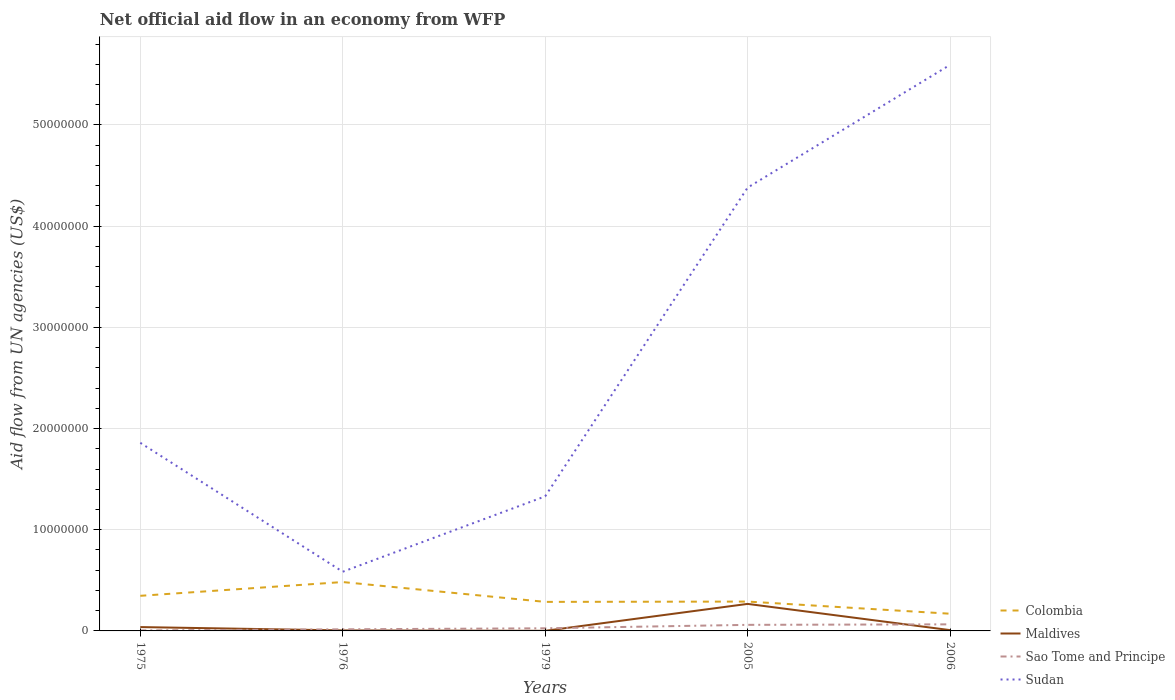How many different coloured lines are there?
Ensure brevity in your answer.  4. Does the line corresponding to Maldives intersect with the line corresponding to Sao Tome and Principe?
Ensure brevity in your answer.  Yes. In which year was the net official aid flow in Colombia maximum?
Ensure brevity in your answer.  2006. What is the total net official aid flow in Sao Tome and Principe in the graph?
Offer a terse response. -3.40e+05. What is the difference between the highest and the second highest net official aid flow in Sudan?
Provide a short and direct response. 5.01e+07. Is the net official aid flow in Maldives strictly greater than the net official aid flow in Sudan over the years?
Give a very brief answer. Yes. How many years are there in the graph?
Ensure brevity in your answer.  5. Are the values on the major ticks of Y-axis written in scientific E-notation?
Provide a succinct answer. No. Does the graph contain any zero values?
Ensure brevity in your answer.  No. How are the legend labels stacked?
Ensure brevity in your answer.  Vertical. What is the title of the graph?
Offer a very short reply. Net official aid flow in an economy from WFP. Does "Marshall Islands" appear as one of the legend labels in the graph?
Offer a terse response. No. What is the label or title of the X-axis?
Make the answer very short. Years. What is the label or title of the Y-axis?
Your answer should be compact. Aid flow from UN agencies (US$). What is the Aid flow from UN agencies (US$) in Colombia in 1975?
Your response must be concise. 3.47e+06. What is the Aid flow from UN agencies (US$) of Sudan in 1975?
Your response must be concise. 1.86e+07. What is the Aid flow from UN agencies (US$) in Colombia in 1976?
Give a very brief answer. 4.83e+06. What is the Aid flow from UN agencies (US$) in Maldives in 1976?
Provide a short and direct response. 5.00e+04. What is the Aid flow from UN agencies (US$) in Sao Tome and Principe in 1976?
Your response must be concise. 1.60e+05. What is the Aid flow from UN agencies (US$) of Sudan in 1976?
Offer a terse response. 5.85e+06. What is the Aid flow from UN agencies (US$) of Colombia in 1979?
Keep it short and to the point. 2.87e+06. What is the Aid flow from UN agencies (US$) in Maldives in 1979?
Make the answer very short. 10000. What is the Aid flow from UN agencies (US$) of Sudan in 1979?
Your answer should be compact. 1.33e+07. What is the Aid flow from UN agencies (US$) of Colombia in 2005?
Offer a terse response. 2.90e+06. What is the Aid flow from UN agencies (US$) in Maldives in 2005?
Your response must be concise. 2.67e+06. What is the Aid flow from UN agencies (US$) in Sao Tome and Principe in 2005?
Provide a succinct answer. 6.00e+05. What is the Aid flow from UN agencies (US$) in Sudan in 2005?
Give a very brief answer. 4.38e+07. What is the Aid flow from UN agencies (US$) of Colombia in 2006?
Ensure brevity in your answer.  1.70e+06. What is the Aid flow from UN agencies (US$) of Sao Tome and Principe in 2006?
Your response must be concise. 6.50e+05. What is the Aid flow from UN agencies (US$) in Sudan in 2006?
Provide a short and direct response. 5.59e+07. Across all years, what is the maximum Aid flow from UN agencies (US$) of Colombia?
Your response must be concise. 4.83e+06. Across all years, what is the maximum Aid flow from UN agencies (US$) of Maldives?
Provide a short and direct response. 2.67e+06. Across all years, what is the maximum Aid flow from UN agencies (US$) of Sao Tome and Principe?
Your response must be concise. 6.50e+05. Across all years, what is the maximum Aid flow from UN agencies (US$) in Sudan?
Your answer should be compact. 5.59e+07. Across all years, what is the minimum Aid flow from UN agencies (US$) in Colombia?
Ensure brevity in your answer.  1.70e+06. Across all years, what is the minimum Aid flow from UN agencies (US$) in Maldives?
Give a very brief answer. 10000. Across all years, what is the minimum Aid flow from UN agencies (US$) of Sudan?
Make the answer very short. 5.85e+06. What is the total Aid flow from UN agencies (US$) of Colombia in the graph?
Your response must be concise. 1.58e+07. What is the total Aid flow from UN agencies (US$) in Maldives in the graph?
Make the answer very short. 3.19e+06. What is the total Aid flow from UN agencies (US$) of Sao Tome and Principe in the graph?
Ensure brevity in your answer.  1.72e+06. What is the total Aid flow from UN agencies (US$) of Sudan in the graph?
Give a very brief answer. 1.37e+08. What is the difference between the Aid flow from UN agencies (US$) of Colombia in 1975 and that in 1976?
Your answer should be very brief. -1.36e+06. What is the difference between the Aid flow from UN agencies (US$) in Maldives in 1975 and that in 1976?
Offer a very short reply. 3.30e+05. What is the difference between the Aid flow from UN agencies (US$) in Sao Tome and Principe in 1975 and that in 1976?
Provide a short and direct response. -1.10e+05. What is the difference between the Aid flow from UN agencies (US$) of Sudan in 1975 and that in 1976?
Offer a very short reply. 1.27e+07. What is the difference between the Aid flow from UN agencies (US$) in Sudan in 1975 and that in 1979?
Your response must be concise. 5.29e+06. What is the difference between the Aid flow from UN agencies (US$) of Colombia in 1975 and that in 2005?
Ensure brevity in your answer.  5.70e+05. What is the difference between the Aid flow from UN agencies (US$) in Maldives in 1975 and that in 2005?
Your answer should be very brief. -2.29e+06. What is the difference between the Aid flow from UN agencies (US$) in Sao Tome and Principe in 1975 and that in 2005?
Keep it short and to the point. -5.50e+05. What is the difference between the Aid flow from UN agencies (US$) in Sudan in 1975 and that in 2005?
Provide a short and direct response. -2.52e+07. What is the difference between the Aid flow from UN agencies (US$) of Colombia in 1975 and that in 2006?
Provide a succinct answer. 1.77e+06. What is the difference between the Aid flow from UN agencies (US$) of Maldives in 1975 and that in 2006?
Provide a short and direct response. 3.00e+05. What is the difference between the Aid flow from UN agencies (US$) of Sao Tome and Principe in 1975 and that in 2006?
Keep it short and to the point. -6.00e+05. What is the difference between the Aid flow from UN agencies (US$) in Sudan in 1975 and that in 2006?
Offer a terse response. -3.74e+07. What is the difference between the Aid flow from UN agencies (US$) in Colombia in 1976 and that in 1979?
Your answer should be very brief. 1.96e+06. What is the difference between the Aid flow from UN agencies (US$) in Maldives in 1976 and that in 1979?
Ensure brevity in your answer.  4.00e+04. What is the difference between the Aid flow from UN agencies (US$) of Sudan in 1976 and that in 1979?
Your response must be concise. -7.45e+06. What is the difference between the Aid flow from UN agencies (US$) of Colombia in 1976 and that in 2005?
Make the answer very short. 1.93e+06. What is the difference between the Aid flow from UN agencies (US$) of Maldives in 1976 and that in 2005?
Provide a succinct answer. -2.62e+06. What is the difference between the Aid flow from UN agencies (US$) of Sao Tome and Principe in 1976 and that in 2005?
Make the answer very short. -4.40e+05. What is the difference between the Aid flow from UN agencies (US$) of Sudan in 1976 and that in 2005?
Your response must be concise. -3.80e+07. What is the difference between the Aid flow from UN agencies (US$) in Colombia in 1976 and that in 2006?
Provide a short and direct response. 3.13e+06. What is the difference between the Aid flow from UN agencies (US$) of Maldives in 1976 and that in 2006?
Provide a short and direct response. -3.00e+04. What is the difference between the Aid flow from UN agencies (US$) in Sao Tome and Principe in 1976 and that in 2006?
Make the answer very short. -4.90e+05. What is the difference between the Aid flow from UN agencies (US$) of Sudan in 1976 and that in 2006?
Your response must be concise. -5.01e+07. What is the difference between the Aid flow from UN agencies (US$) of Maldives in 1979 and that in 2005?
Keep it short and to the point. -2.66e+06. What is the difference between the Aid flow from UN agencies (US$) of Sudan in 1979 and that in 2005?
Ensure brevity in your answer.  -3.05e+07. What is the difference between the Aid flow from UN agencies (US$) in Colombia in 1979 and that in 2006?
Offer a terse response. 1.17e+06. What is the difference between the Aid flow from UN agencies (US$) of Sao Tome and Principe in 1979 and that in 2006?
Offer a terse response. -3.90e+05. What is the difference between the Aid flow from UN agencies (US$) in Sudan in 1979 and that in 2006?
Offer a terse response. -4.26e+07. What is the difference between the Aid flow from UN agencies (US$) in Colombia in 2005 and that in 2006?
Provide a succinct answer. 1.20e+06. What is the difference between the Aid flow from UN agencies (US$) of Maldives in 2005 and that in 2006?
Your answer should be very brief. 2.59e+06. What is the difference between the Aid flow from UN agencies (US$) in Sudan in 2005 and that in 2006?
Your answer should be very brief. -1.21e+07. What is the difference between the Aid flow from UN agencies (US$) of Colombia in 1975 and the Aid flow from UN agencies (US$) of Maldives in 1976?
Your response must be concise. 3.42e+06. What is the difference between the Aid flow from UN agencies (US$) of Colombia in 1975 and the Aid flow from UN agencies (US$) of Sao Tome and Principe in 1976?
Ensure brevity in your answer.  3.31e+06. What is the difference between the Aid flow from UN agencies (US$) of Colombia in 1975 and the Aid flow from UN agencies (US$) of Sudan in 1976?
Offer a terse response. -2.38e+06. What is the difference between the Aid flow from UN agencies (US$) of Maldives in 1975 and the Aid flow from UN agencies (US$) of Sudan in 1976?
Offer a terse response. -5.47e+06. What is the difference between the Aid flow from UN agencies (US$) of Sao Tome and Principe in 1975 and the Aid flow from UN agencies (US$) of Sudan in 1976?
Your answer should be compact. -5.80e+06. What is the difference between the Aid flow from UN agencies (US$) in Colombia in 1975 and the Aid flow from UN agencies (US$) in Maldives in 1979?
Ensure brevity in your answer.  3.46e+06. What is the difference between the Aid flow from UN agencies (US$) in Colombia in 1975 and the Aid flow from UN agencies (US$) in Sao Tome and Principe in 1979?
Keep it short and to the point. 3.21e+06. What is the difference between the Aid flow from UN agencies (US$) in Colombia in 1975 and the Aid flow from UN agencies (US$) in Sudan in 1979?
Provide a succinct answer. -9.83e+06. What is the difference between the Aid flow from UN agencies (US$) of Maldives in 1975 and the Aid flow from UN agencies (US$) of Sao Tome and Principe in 1979?
Offer a terse response. 1.20e+05. What is the difference between the Aid flow from UN agencies (US$) of Maldives in 1975 and the Aid flow from UN agencies (US$) of Sudan in 1979?
Offer a very short reply. -1.29e+07. What is the difference between the Aid flow from UN agencies (US$) in Sao Tome and Principe in 1975 and the Aid flow from UN agencies (US$) in Sudan in 1979?
Your answer should be compact. -1.32e+07. What is the difference between the Aid flow from UN agencies (US$) in Colombia in 1975 and the Aid flow from UN agencies (US$) in Maldives in 2005?
Your answer should be compact. 8.00e+05. What is the difference between the Aid flow from UN agencies (US$) in Colombia in 1975 and the Aid flow from UN agencies (US$) in Sao Tome and Principe in 2005?
Give a very brief answer. 2.87e+06. What is the difference between the Aid flow from UN agencies (US$) of Colombia in 1975 and the Aid flow from UN agencies (US$) of Sudan in 2005?
Your answer should be compact. -4.03e+07. What is the difference between the Aid flow from UN agencies (US$) of Maldives in 1975 and the Aid flow from UN agencies (US$) of Sao Tome and Principe in 2005?
Keep it short and to the point. -2.20e+05. What is the difference between the Aid flow from UN agencies (US$) of Maldives in 1975 and the Aid flow from UN agencies (US$) of Sudan in 2005?
Make the answer very short. -4.34e+07. What is the difference between the Aid flow from UN agencies (US$) of Sao Tome and Principe in 1975 and the Aid flow from UN agencies (US$) of Sudan in 2005?
Your response must be concise. -4.38e+07. What is the difference between the Aid flow from UN agencies (US$) of Colombia in 1975 and the Aid flow from UN agencies (US$) of Maldives in 2006?
Keep it short and to the point. 3.39e+06. What is the difference between the Aid flow from UN agencies (US$) in Colombia in 1975 and the Aid flow from UN agencies (US$) in Sao Tome and Principe in 2006?
Your answer should be very brief. 2.82e+06. What is the difference between the Aid flow from UN agencies (US$) in Colombia in 1975 and the Aid flow from UN agencies (US$) in Sudan in 2006?
Your response must be concise. -5.25e+07. What is the difference between the Aid flow from UN agencies (US$) in Maldives in 1975 and the Aid flow from UN agencies (US$) in Sao Tome and Principe in 2006?
Provide a succinct answer. -2.70e+05. What is the difference between the Aid flow from UN agencies (US$) in Maldives in 1975 and the Aid flow from UN agencies (US$) in Sudan in 2006?
Ensure brevity in your answer.  -5.56e+07. What is the difference between the Aid flow from UN agencies (US$) in Sao Tome and Principe in 1975 and the Aid flow from UN agencies (US$) in Sudan in 2006?
Provide a succinct answer. -5.59e+07. What is the difference between the Aid flow from UN agencies (US$) of Colombia in 1976 and the Aid flow from UN agencies (US$) of Maldives in 1979?
Keep it short and to the point. 4.82e+06. What is the difference between the Aid flow from UN agencies (US$) in Colombia in 1976 and the Aid flow from UN agencies (US$) in Sao Tome and Principe in 1979?
Offer a terse response. 4.57e+06. What is the difference between the Aid flow from UN agencies (US$) of Colombia in 1976 and the Aid flow from UN agencies (US$) of Sudan in 1979?
Keep it short and to the point. -8.47e+06. What is the difference between the Aid flow from UN agencies (US$) in Maldives in 1976 and the Aid flow from UN agencies (US$) in Sudan in 1979?
Offer a terse response. -1.32e+07. What is the difference between the Aid flow from UN agencies (US$) of Sao Tome and Principe in 1976 and the Aid flow from UN agencies (US$) of Sudan in 1979?
Provide a succinct answer. -1.31e+07. What is the difference between the Aid flow from UN agencies (US$) in Colombia in 1976 and the Aid flow from UN agencies (US$) in Maldives in 2005?
Offer a very short reply. 2.16e+06. What is the difference between the Aid flow from UN agencies (US$) of Colombia in 1976 and the Aid flow from UN agencies (US$) of Sao Tome and Principe in 2005?
Give a very brief answer. 4.23e+06. What is the difference between the Aid flow from UN agencies (US$) in Colombia in 1976 and the Aid flow from UN agencies (US$) in Sudan in 2005?
Your answer should be compact. -3.90e+07. What is the difference between the Aid flow from UN agencies (US$) of Maldives in 1976 and the Aid flow from UN agencies (US$) of Sao Tome and Principe in 2005?
Make the answer very short. -5.50e+05. What is the difference between the Aid flow from UN agencies (US$) in Maldives in 1976 and the Aid flow from UN agencies (US$) in Sudan in 2005?
Offer a terse response. -4.38e+07. What is the difference between the Aid flow from UN agencies (US$) in Sao Tome and Principe in 1976 and the Aid flow from UN agencies (US$) in Sudan in 2005?
Offer a terse response. -4.36e+07. What is the difference between the Aid flow from UN agencies (US$) in Colombia in 1976 and the Aid flow from UN agencies (US$) in Maldives in 2006?
Offer a very short reply. 4.75e+06. What is the difference between the Aid flow from UN agencies (US$) in Colombia in 1976 and the Aid flow from UN agencies (US$) in Sao Tome and Principe in 2006?
Your answer should be compact. 4.18e+06. What is the difference between the Aid flow from UN agencies (US$) in Colombia in 1976 and the Aid flow from UN agencies (US$) in Sudan in 2006?
Your response must be concise. -5.11e+07. What is the difference between the Aid flow from UN agencies (US$) of Maldives in 1976 and the Aid flow from UN agencies (US$) of Sao Tome and Principe in 2006?
Your answer should be compact. -6.00e+05. What is the difference between the Aid flow from UN agencies (US$) of Maldives in 1976 and the Aid flow from UN agencies (US$) of Sudan in 2006?
Make the answer very short. -5.59e+07. What is the difference between the Aid flow from UN agencies (US$) of Sao Tome and Principe in 1976 and the Aid flow from UN agencies (US$) of Sudan in 2006?
Provide a short and direct response. -5.58e+07. What is the difference between the Aid flow from UN agencies (US$) in Colombia in 1979 and the Aid flow from UN agencies (US$) in Sao Tome and Principe in 2005?
Your response must be concise. 2.27e+06. What is the difference between the Aid flow from UN agencies (US$) of Colombia in 1979 and the Aid flow from UN agencies (US$) of Sudan in 2005?
Keep it short and to the point. -4.09e+07. What is the difference between the Aid flow from UN agencies (US$) in Maldives in 1979 and the Aid flow from UN agencies (US$) in Sao Tome and Principe in 2005?
Keep it short and to the point. -5.90e+05. What is the difference between the Aid flow from UN agencies (US$) in Maldives in 1979 and the Aid flow from UN agencies (US$) in Sudan in 2005?
Ensure brevity in your answer.  -4.38e+07. What is the difference between the Aid flow from UN agencies (US$) in Sao Tome and Principe in 1979 and the Aid flow from UN agencies (US$) in Sudan in 2005?
Your response must be concise. -4.36e+07. What is the difference between the Aid flow from UN agencies (US$) of Colombia in 1979 and the Aid flow from UN agencies (US$) of Maldives in 2006?
Your response must be concise. 2.79e+06. What is the difference between the Aid flow from UN agencies (US$) of Colombia in 1979 and the Aid flow from UN agencies (US$) of Sao Tome and Principe in 2006?
Give a very brief answer. 2.22e+06. What is the difference between the Aid flow from UN agencies (US$) of Colombia in 1979 and the Aid flow from UN agencies (US$) of Sudan in 2006?
Ensure brevity in your answer.  -5.31e+07. What is the difference between the Aid flow from UN agencies (US$) in Maldives in 1979 and the Aid flow from UN agencies (US$) in Sao Tome and Principe in 2006?
Offer a terse response. -6.40e+05. What is the difference between the Aid flow from UN agencies (US$) in Maldives in 1979 and the Aid flow from UN agencies (US$) in Sudan in 2006?
Provide a short and direct response. -5.59e+07. What is the difference between the Aid flow from UN agencies (US$) of Sao Tome and Principe in 1979 and the Aid flow from UN agencies (US$) of Sudan in 2006?
Ensure brevity in your answer.  -5.57e+07. What is the difference between the Aid flow from UN agencies (US$) in Colombia in 2005 and the Aid flow from UN agencies (US$) in Maldives in 2006?
Your answer should be compact. 2.82e+06. What is the difference between the Aid flow from UN agencies (US$) of Colombia in 2005 and the Aid flow from UN agencies (US$) of Sao Tome and Principe in 2006?
Provide a short and direct response. 2.25e+06. What is the difference between the Aid flow from UN agencies (US$) of Colombia in 2005 and the Aid flow from UN agencies (US$) of Sudan in 2006?
Your answer should be compact. -5.30e+07. What is the difference between the Aid flow from UN agencies (US$) of Maldives in 2005 and the Aid flow from UN agencies (US$) of Sao Tome and Principe in 2006?
Your answer should be compact. 2.02e+06. What is the difference between the Aid flow from UN agencies (US$) of Maldives in 2005 and the Aid flow from UN agencies (US$) of Sudan in 2006?
Give a very brief answer. -5.33e+07. What is the difference between the Aid flow from UN agencies (US$) of Sao Tome and Principe in 2005 and the Aid flow from UN agencies (US$) of Sudan in 2006?
Provide a short and direct response. -5.53e+07. What is the average Aid flow from UN agencies (US$) in Colombia per year?
Your response must be concise. 3.15e+06. What is the average Aid flow from UN agencies (US$) of Maldives per year?
Offer a terse response. 6.38e+05. What is the average Aid flow from UN agencies (US$) of Sao Tome and Principe per year?
Ensure brevity in your answer.  3.44e+05. What is the average Aid flow from UN agencies (US$) in Sudan per year?
Ensure brevity in your answer.  2.75e+07. In the year 1975, what is the difference between the Aid flow from UN agencies (US$) of Colombia and Aid flow from UN agencies (US$) of Maldives?
Provide a succinct answer. 3.09e+06. In the year 1975, what is the difference between the Aid flow from UN agencies (US$) of Colombia and Aid flow from UN agencies (US$) of Sao Tome and Principe?
Offer a terse response. 3.42e+06. In the year 1975, what is the difference between the Aid flow from UN agencies (US$) of Colombia and Aid flow from UN agencies (US$) of Sudan?
Your answer should be compact. -1.51e+07. In the year 1975, what is the difference between the Aid flow from UN agencies (US$) in Maldives and Aid flow from UN agencies (US$) in Sao Tome and Principe?
Make the answer very short. 3.30e+05. In the year 1975, what is the difference between the Aid flow from UN agencies (US$) in Maldives and Aid flow from UN agencies (US$) in Sudan?
Your answer should be very brief. -1.82e+07. In the year 1975, what is the difference between the Aid flow from UN agencies (US$) of Sao Tome and Principe and Aid flow from UN agencies (US$) of Sudan?
Offer a very short reply. -1.85e+07. In the year 1976, what is the difference between the Aid flow from UN agencies (US$) in Colombia and Aid flow from UN agencies (US$) in Maldives?
Make the answer very short. 4.78e+06. In the year 1976, what is the difference between the Aid flow from UN agencies (US$) in Colombia and Aid flow from UN agencies (US$) in Sao Tome and Principe?
Offer a terse response. 4.67e+06. In the year 1976, what is the difference between the Aid flow from UN agencies (US$) of Colombia and Aid flow from UN agencies (US$) of Sudan?
Your answer should be compact. -1.02e+06. In the year 1976, what is the difference between the Aid flow from UN agencies (US$) of Maldives and Aid flow from UN agencies (US$) of Sudan?
Ensure brevity in your answer.  -5.80e+06. In the year 1976, what is the difference between the Aid flow from UN agencies (US$) in Sao Tome and Principe and Aid flow from UN agencies (US$) in Sudan?
Give a very brief answer. -5.69e+06. In the year 1979, what is the difference between the Aid flow from UN agencies (US$) in Colombia and Aid flow from UN agencies (US$) in Maldives?
Provide a short and direct response. 2.86e+06. In the year 1979, what is the difference between the Aid flow from UN agencies (US$) of Colombia and Aid flow from UN agencies (US$) of Sao Tome and Principe?
Offer a terse response. 2.61e+06. In the year 1979, what is the difference between the Aid flow from UN agencies (US$) in Colombia and Aid flow from UN agencies (US$) in Sudan?
Your response must be concise. -1.04e+07. In the year 1979, what is the difference between the Aid flow from UN agencies (US$) of Maldives and Aid flow from UN agencies (US$) of Sudan?
Your answer should be compact. -1.33e+07. In the year 1979, what is the difference between the Aid flow from UN agencies (US$) of Sao Tome and Principe and Aid flow from UN agencies (US$) of Sudan?
Your answer should be compact. -1.30e+07. In the year 2005, what is the difference between the Aid flow from UN agencies (US$) in Colombia and Aid flow from UN agencies (US$) in Maldives?
Provide a succinct answer. 2.30e+05. In the year 2005, what is the difference between the Aid flow from UN agencies (US$) of Colombia and Aid flow from UN agencies (US$) of Sao Tome and Principe?
Ensure brevity in your answer.  2.30e+06. In the year 2005, what is the difference between the Aid flow from UN agencies (US$) of Colombia and Aid flow from UN agencies (US$) of Sudan?
Offer a very short reply. -4.09e+07. In the year 2005, what is the difference between the Aid flow from UN agencies (US$) in Maldives and Aid flow from UN agencies (US$) in Sao Tome and Principe?
Offer a terse response. 2.07e+06. In the year 2005, what is the difference between the Aid flow from UN agencies (US$) of Maldives and Aid flow from UN agencies (US$) of Sudan?
Your answer should be very brief. -4.11e+07. In the year 2005, what is the difference between the Aid flow from UN agencies (US$) in Sao Tome and Principe and Aid flow from UN agencies (US$) in Sudan?
Give a very brief answer. -4.32e+07. In the year 2006, what is the difference between the Aid flow from UN agencies (US$) in Colombia and Aid flow from UN agencies (US$) in Maldives?
Give a very brief answer. 1.62e+06. In the year 2006, what is the difference between the Aid flow from UN agencies (US$) in Colombia and Aid flow from UN agencies (US$) in Sao Tome and Principe?
Offer a very short reply. 1.05e+06. In the year 2006, what is the difference between the Aid flow from UN agencies (US$) in Colombia and Aid flow from UN agencies (US$) in Sudan?
Offer a very short reply. -5.42e+07. In the year 2006, what is the difference between the Aid flow from UN agencies (US$) in Maldives and Aid flow from UN agencies (US$) in Sao Tome and Principe?
Your answer should be compact. -5.70e+05. In the year 2006, what is the difference between the Aid flow from UN agencies (US$) of Maldives and Aid flow from UN agencies (US$) of Sudan?
Offer a terse response. -5.59e+07. In the year 2006, what is the difference between the Aid flow from UN agencies (US$) in Sao Tome and Principe and Aid flow from UN agencies (US$) in Sudan?
Offer a terse response. -5.53e+07. What is the ratio of the Aid flow from UN agencies (US$) in Colombia in 1975 to that in 1976?
Offer a very short reply. 0.72. What is the ratio of the Aid flow from UN agencies (US$) of Sao Tome and Principe in 1975 to that in 1976?
Your answer should be very brief. 0.31. What is the ratio of the Aid flow from UN agencies (US$) in Sudan in 1975 to that in 1976?
Keep it short and to the point. 3.18. What is the ratio of the Aid flow from UN agencies (US$) of Colombia in 1975 to that in 1979?
Your answer should be very brief. 1.21. What is the ratio of the Aid flow from UN agencies (US$) of Sao Tome and Principe in 1975 to that in 1979?
Provide a succinct answer. 0.19. What is the ratio of the Aid flow from UN agencies (US$) of Sudan in 1975 to that in 1979?
Your response must be concise. 1.4. What is the ratio of the Aid flow from UN agencies (US$) in Colombia in 1975 to that in 2005?
Your response must be concise. 1.2. What is the ratio of the Aid flow from UN agencies (US$) of Maldives in 1975 to that in 2005?
Your answer should be compact. 0.14. What is the ratio of the Aid flow from UN agencies (US$) of Sao Tome and Principe in 1975 to that in 2005?
Offer a very short reply. 0.08. What is the ratio of the Aid flow from UN agencies (US$) of Sudan in 1975 to that in 2005?
Make the answer very short. 0.42. What is the ratio of the Aid flow from UN agencies (US$) in Colombia in 1975 to that in 2006?
Ensure brevity in your answer.  2.04. What is the ratio of the Aid flow from UN agencies (US$) of Maldives in 1975 to that in 2006?
Give a very brief answer. 4.75. What is the ratio of the Aid flow from UN agencies (US$) of Sao Tome and Principe in 1975 to that in 2006?
Offer a very short reply. 0.08. What is the ratio of the Aid flow from UN agencies (US$) in Sudan in 1975 to that in 2006?
Keep it short and to the point. 0.33. What is the ratio of the Aid flow from UN agencies (US$) in Colombia in 1976 to that in 1979?
Ensure brevity in your answer.  1.68. What is the ratio of the Aid flow from UN agencies (US$) of Sao Tome and Principe in 1976 to that in 1979?
Offer a very short reply. 0.62. What is the ratio of the Aid flow from UN agencies (US$) in Sudan in 1976 to that in 1979?
Give a very brief answer. 0.44. What is the ratio of the Aid flow from UN agencies (US$) in Colombia in 1976 to that in 2005?
Your answer should be very brief. 1.67. What is the ratio of the Aid flow from UN agencies (US$) in Maldives in 1976 to that in 2005?
Give a very brief answer. 0.02. What is the ratio of the Aid flow from UN agencies (US$) in Sao Tome and Principe in 1976 to that in 2005?
Make the answer very short. 0.27. What is the ratio of the Aid flow from UN agencies (US$) in Sudan in 1976 to that in 2005?
Make the answer very short. 0.13. What is the ratio of the Aid flow from UN agencies (US$) of Colombia in 1976 to that in 2006?
Your response must be concise. 2.84. What is the ratio of the Aid flow from UN agencies (US$) of Sao Tome and Principe in 1976 to that in 2006?
Your response must be concise. 0.25. What is the ratio of the Aid flow from UN agencies (US$) of Sudan in 1976 to that in 2006?
Provide a short and direct response. 0.1. What is the ratio of the Aid flow from UN agencies (US$) of Maldives in 1979 to that in 2005?
Your response must be concise. 0. What is the ratio of the Aid flow from UN agencies (US$) of Sao Tome and Principe in 1979 to that in 2005?
Provide a short and direct response. 0.43. What is the ratio of the Aid flow from UN agencies (US$) of Sudan in 1979 to that in 2005?
Provide a succinct answer. 0.3. What is the ratio of the Aid flow from UN agencies (US$) of Colombia in 1979 to that in 2006?
Give a very brief answer. 1.69. What is the ratio of the Aid flow from UN agencies (US$) in Maldives in 1979 to that in 2006?
Offer a very short reply. 0.12. What is the ratio of the Aid flow from UN agencies (US$) in Sao Tome and Principe in 1979 to that in 2006?
Give a very brief answer. 0.4. What is the ratio of the Aid flow from UN agencies (US$) of Sudan in 1979 to that in 2006?
Provide a short and direct response. 0.24. What is the ratio of the Aid flow from UN agencies (US$) of Colombia in 2005 to that in 2006?
Offer a very short reply. 1.71. What is the ratio of the Aid flow from UN agencies (US$) in Maldives in 2005 to that in 2006?
Offer a terse response. 33.38. What is the ratio of the Aid flow from UN agencies (US$) in Sao Tome and Principe in 2005 to that in 2006?
Provide a short and direct response. 0.92. What is the ratio of the Aid flow from UN agencies (US$) of Sudan in 2005 to that in 2006?
Give a very brief answer. 0.78. What is the difference between the highest and the second highest Aid flow from UN agencies (US$) of Colombia?
Your answer should be compact. 1.36e+06. What is the difference between the highest and the second highest Aid flow from UN agencies (US$) of Maldives?
Make the answer very short. 2.29e+06. What is the difference between the highest and the second highest Aid flow from UN agencies (US$) in Sudan?
Your answer should be very brief. 1.21e+07. What is the difference between the highest and the lowest Aid flow from UN agencies (US$) in Colombia?
Ensure brevity in your answer.  3.13e+06. What is the difference between the highest and the lowest Aid flow from UN agencies (US$) in Maldives?
Offer a very short reply. 2.66e+06. What is the difference between the highest and the lowest Aid flow from UN agencies (US$) in Sudan?
Keep it short and to the point. 5.01e+07. 